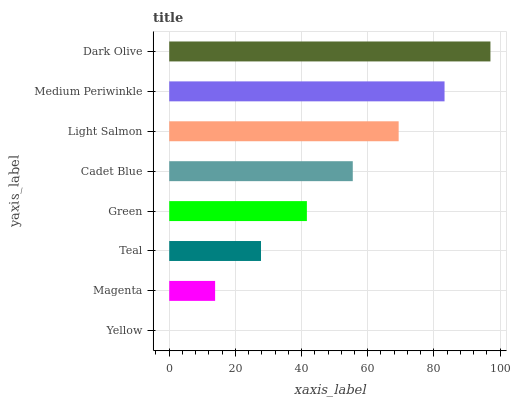Is Yellow the minimum?
Answer yes or no. Yes. Is Dark Olive the maximum?
Answer yes or no. Yes. Is Magenta the minimum?
Answer yes or no. No. Is Magenta the maximum?
Answer yes or no. No. Is Magenta greater than Yellow?
Answer yes or no. Yes. Is Yellow less than Magenta?
Answer yes or no. Yes. Is Yellow greater than Magenta?
Answer yes or no. No. Is Magenta less than Yellow?
Answer yes or no. No. Is Cadet Blue the high median?
Answer yes or no. Yes. Is Green the low median?
Answer yes or no. Yes. Is Magenta the high median?
Answer yes or no. No. Is Yellow the low median?
Answer yes or no. No. 